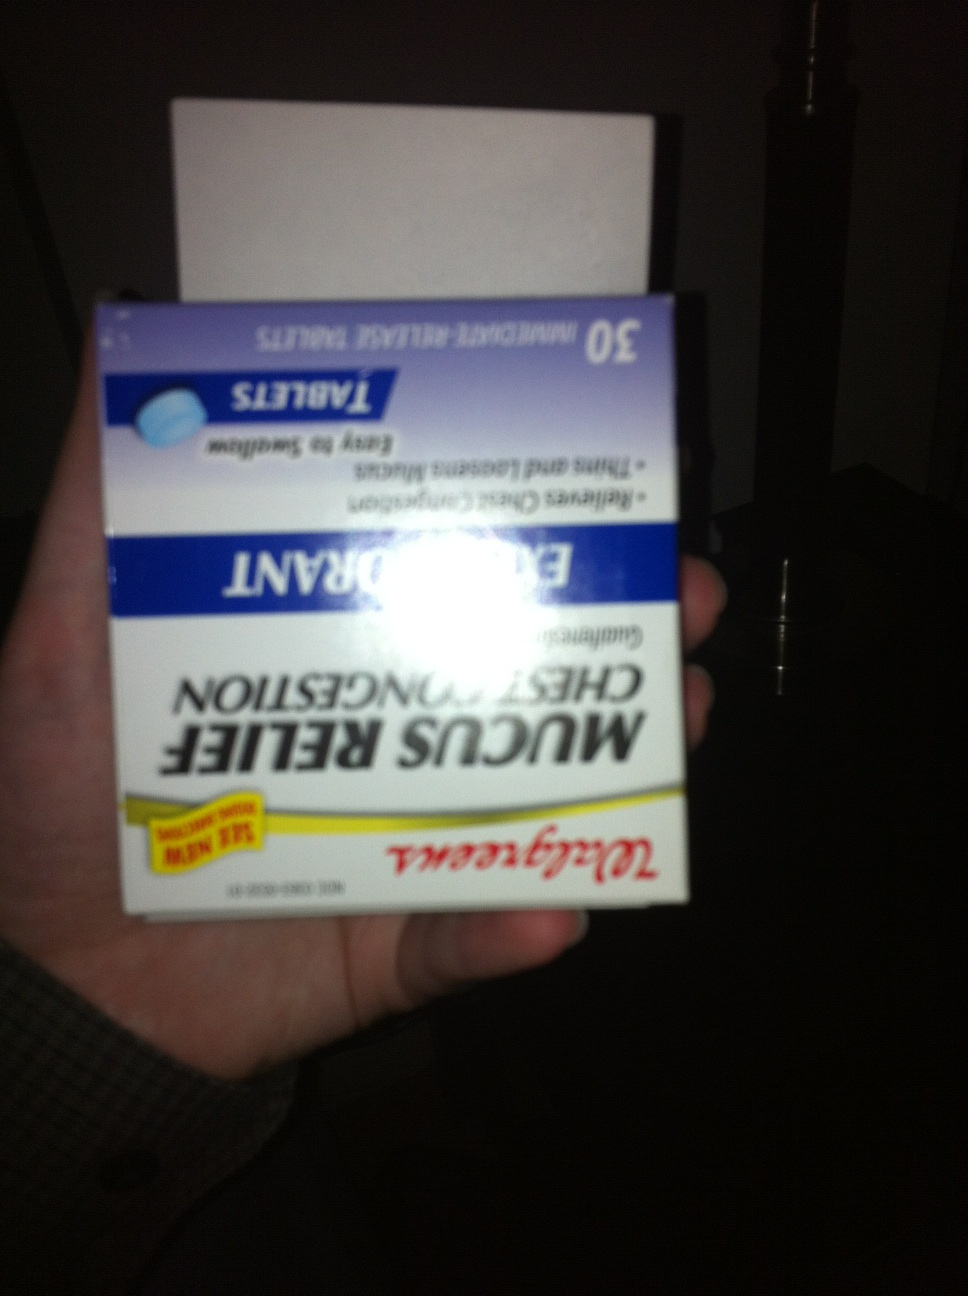Can you describe any potential side effects of this product? Most people do not experience serious side effects when taking Guaifenesin. However, some potential side effects may include dizziness, headache, rash, nausea, and upset stomach. If any of these effects persist or worsen, contact your doctor or pharmacist promptly. Are there any precautions I should take while using this medication? Yes, there are several precautions to consider. Inform your doctor if you have any allergies, as this product may contain inactive ingredients that can cause allergic reactions. Consult your doctor before using if you have a persistent cough from smoking, asthma, or emphysema. It's important to follow the recommended dosage instructions and not to take more than directed. Drink plenty of fluids while taking this medication to help loosen the mucus in your lungs. 